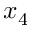Convert formula to latex. <formula><loc_0><loc_0><loc_500><loc_500>x _ { 4 }</formula> 